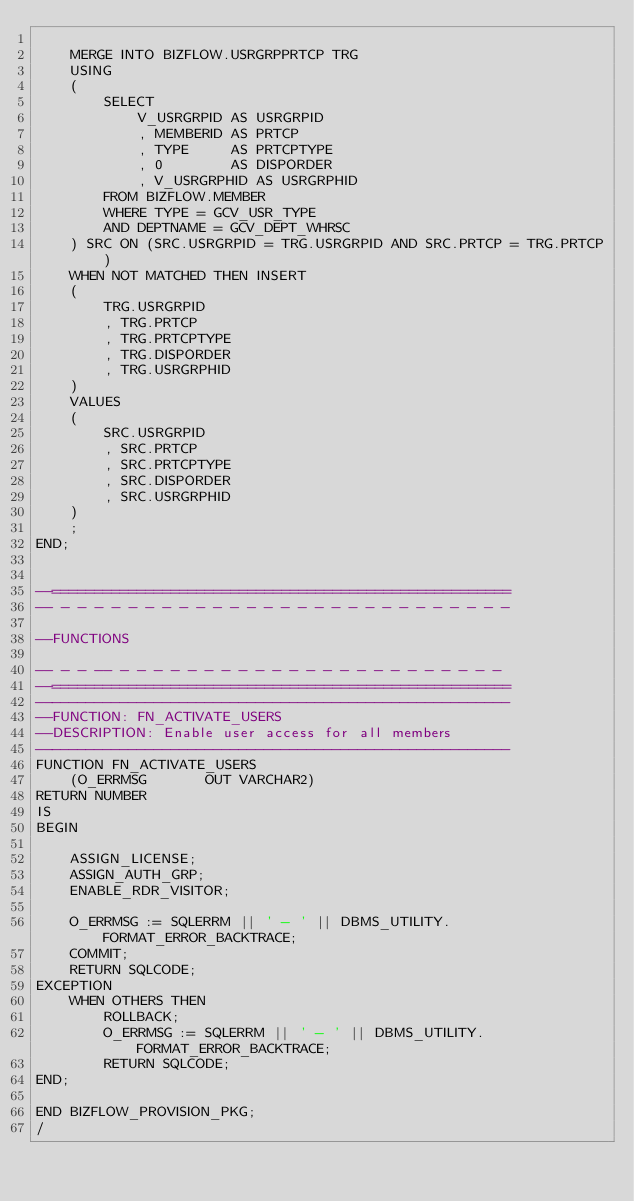Convert code to text. <code><loc_0><loc_0><loc_500><loc_500><_SQL_>
	MERGE INTO BIZFLOW.USRGRPPRTCP TRG
	USING
	(
		SELECT
			V_USRGRPID AS USRGRPID
			, MEMBERID AS PRTCP
			, TYPE     AS PRTCPTYPE
			, 0        AS DISPORDER
			, V_USRGRPHID AS USRGRPHID
		FROM BIZFLOW.MEMBER
		WHERE TYPE = GCV_USR_TYPE
		AND DEPTNAME = GCV_DEPT_WHRSC
	) SRC ON (SRC.USRGRPID = TRG.USRGRPID AND SRC.PRTCP = TRG.PRTCP)
	WHEN NOT MATCHED THEN INSERT
	(
		TRG.USRGRPID
		, TRG.PRTCP
		, TRG.PRTCPTYPE
		, TRG.DISPORDER
		, TRG.USRGRPHID
	)
	VALUES
	(
		SRC.USRGRPID
		, SRC.PRTCP
		, SRC.PRTCPTYPE
		, SRC.DISPORDER
		, SRC.USRGRPHID
	)
	;
END;


--======================================================
-- - - - - - - - - - - - - - - - - - - - - - - - - - - -

--FUNCTIONS

-- - - -- - - - - - - - - - - - - - - - - - - - - - - -
--======================================================
--------------------------------------------------------
--FUNCTION: FN_ACTIVATE_USERS
--DESCRIPTION: Enable user access for all members
--------------------------------------------------------
FUNCTION FN_ACTIVATE_USERS
	(O_ERRMSG       OUT VARCHAR2)
RETURN NUMBER
IS
BEGIN

	ASSIGN_LICENSE;
	ASSIGN_AUTH_GRP;
	ENABLE_RDR_VISITOR;
	
	O_ERRMSG := SQLERRM || ' - ' || DBMS_UTILITY.FORMAT_ERROR_BACKTRACE;
	COMMIT;
	RETURN SQLCODE;
EXCEPTION
	WHEN OTHERS THEN
		ROLLBACK;
		O_ERRMSG := SQLERRM || ' - ' || DBMS_UTILITY.FORMAT_ERROR_BACKTRACE;
		RETURN SQLCODE;
END;

END BIZFLOW_PROVISION_PKG;
/
</code> 